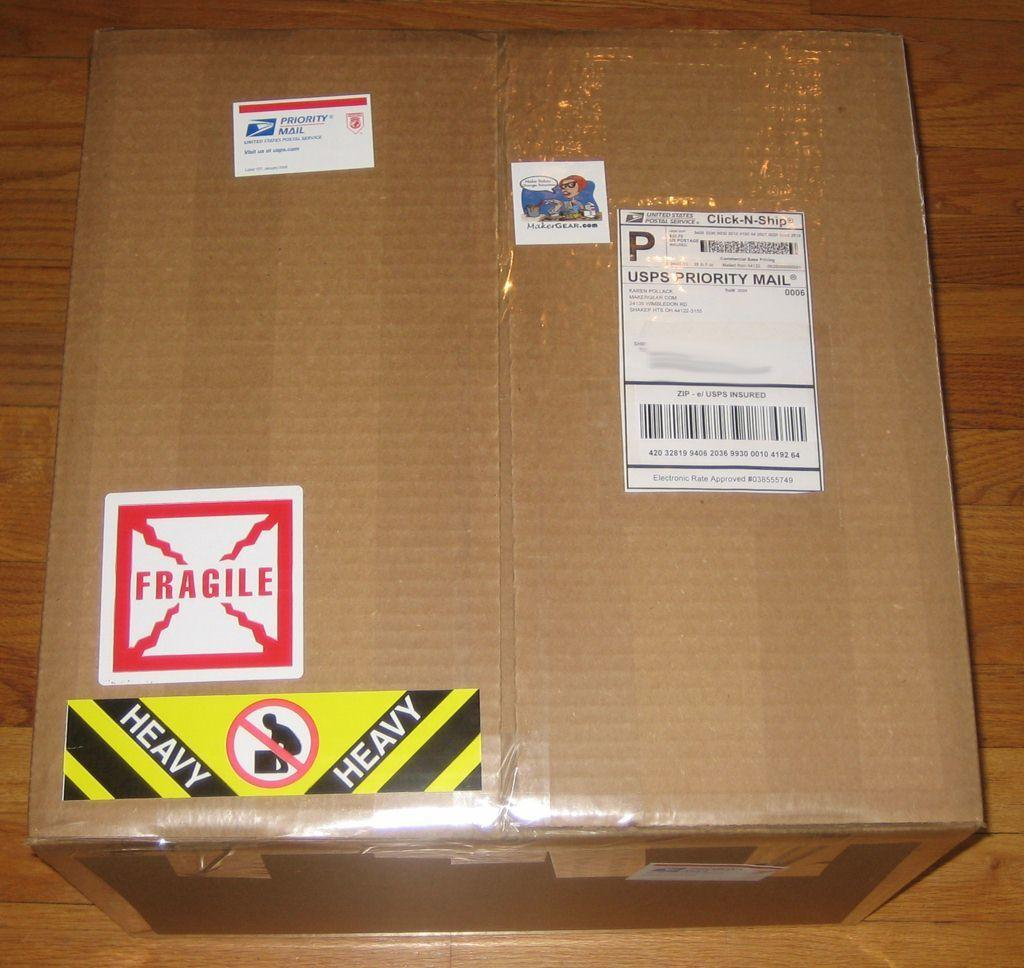<image>
Present a compact description of the photo's key features. One can see a warning on the brown bo that it is a heavy object. 